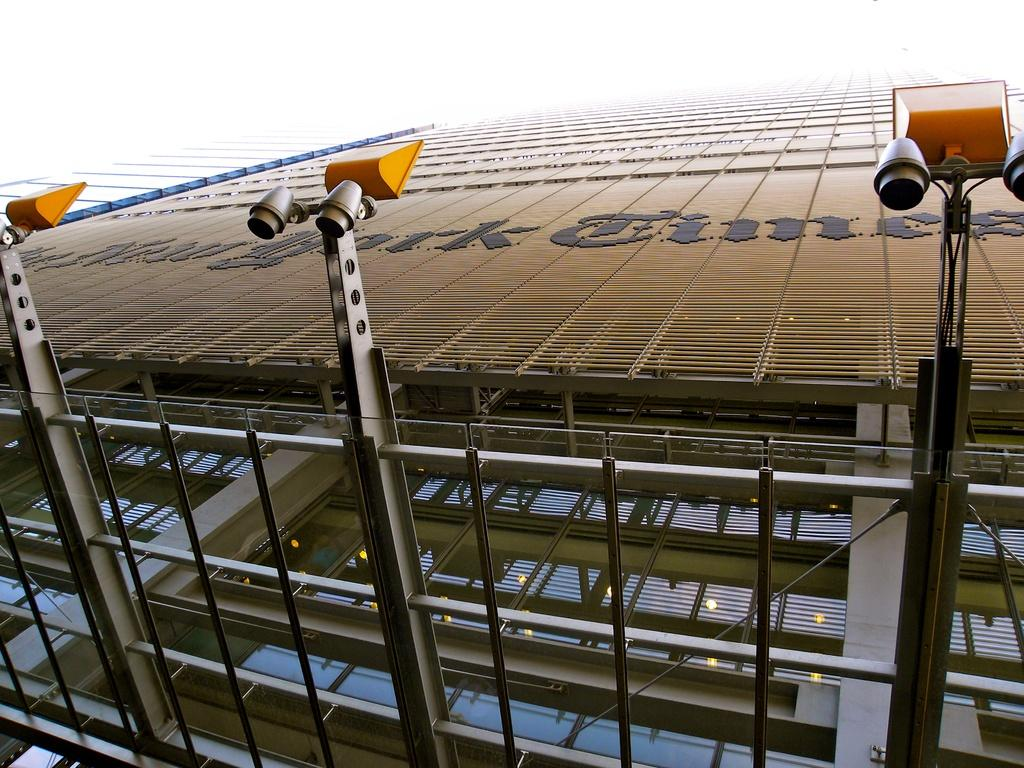What structure is present in the image? There is a building in the image. What can be seen illuminated in the image? There are lights visible in the image. What is visible in the background of the image? The sky is visible in the background of the image. What type of quince dish is being prepared in the image? There is no quince dish or any indication of food preparation in the image. What type of roll can be seen in the image? There is no roll present in the image. 